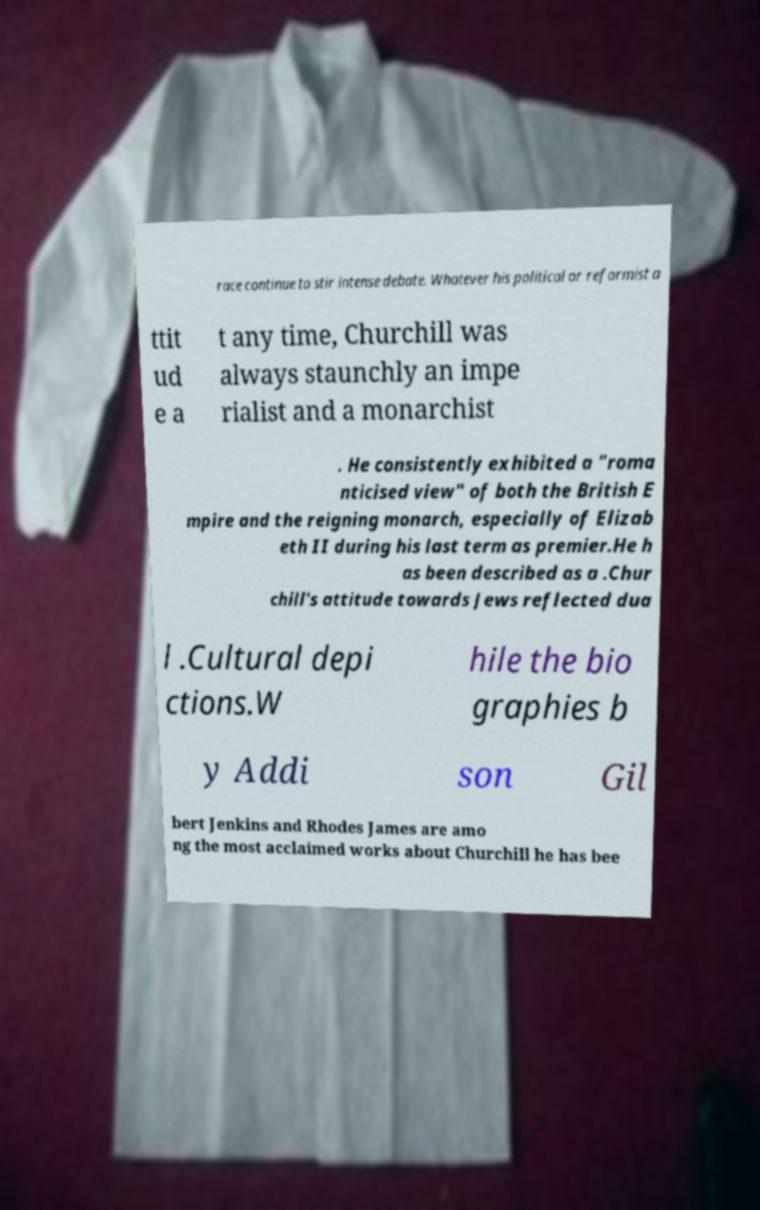For documentation purposes, I need the text within this image transcribed. Could you provide that? race continue to stir intense debate. Whatever his political or reformist a ttit ud e a t any time, Churchill was always staunchly an impe rialist and a monarchist . He consistently exhibited a "roma nticised view" of both the British E mpire and the reigning monarch, especially of Elizab eth II during his last term as premier.He h as been described as a .Chur chill's attitude towards Jews reflected dua l .Cultural depi ctions.W hile the bio graphies b y Addi son Gil bert Jenkins and Rhodes James are amo ng the most acclaimed works about Churchill he has bee 